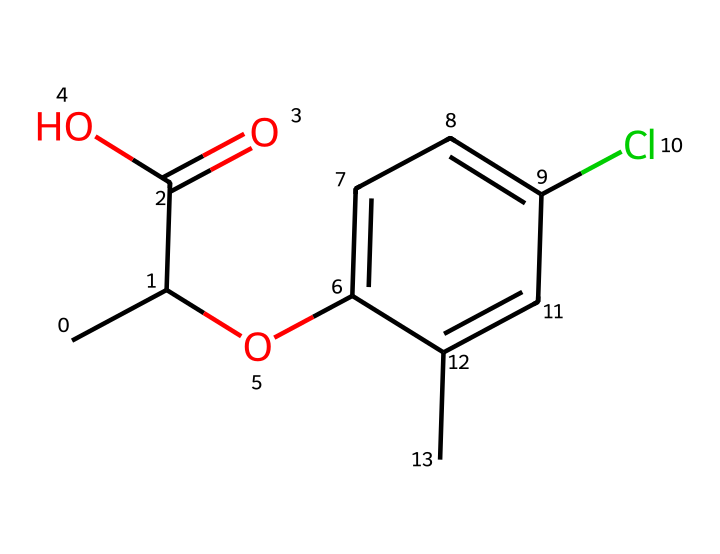What is the primary functional group in mecoprop? In the SMILES representation, the presence of "C(=O)O" indicates a carboxylic acid functional group, which is characterized by the carbon atom double-bonded to an oxygen atom and single-bonded to a hydroxyl group.
Answer: carboxylic acid How many carbon atoms are present in mecoprop? By breaking down the SMILES, there are a total of 9 carbon atoms: 6 in the aromatic ring and 3 in the aliphatic part (the chain and carboxylic acid).
Answer: 9 What type of herbicide is mecoprop classified as? Mecoprop is classified as a selective post-emergence herbicide, meaning it targets specific weeds after they have emerged, allowing for the treatment of lawns without damaging grass.
Answer: selective post-emergence How many chlorine atoms are present in mecoprop? The "Cl" in the chemical structure indicates the presence of one chlorine atom, which can be counted directly from the structure.
Answer: 1 What is the significance of the aromatic ring in mecoprop? The aromatic ring contributes to the herbicide's stability and its ability to interact with biological systems, as aromatic compounds typically have distinct properties, including persistence and potential to absorb light.
Answer: stability What is the molecular formula for mecoprop? By analyzing the SMILES representation, the molecular composition includes 9 carbon atoms, 9 hydrogen atoms (counting all the attached hydrogens), and 2 oxygen atoms, along with 1 chlorine atom, resulting in the molecular formula C9H10ClO3.
Answer: C9H10ClO3 What role does the hydroxyl group play in the function of mecoprop? The hydroxyl group (-OH) can enhance solubility in water and may participate in biochemical reactions, aiding the herbicide's effectiveness in targeting specific biochemical pathways in plants.
Answer: enhances solubility 